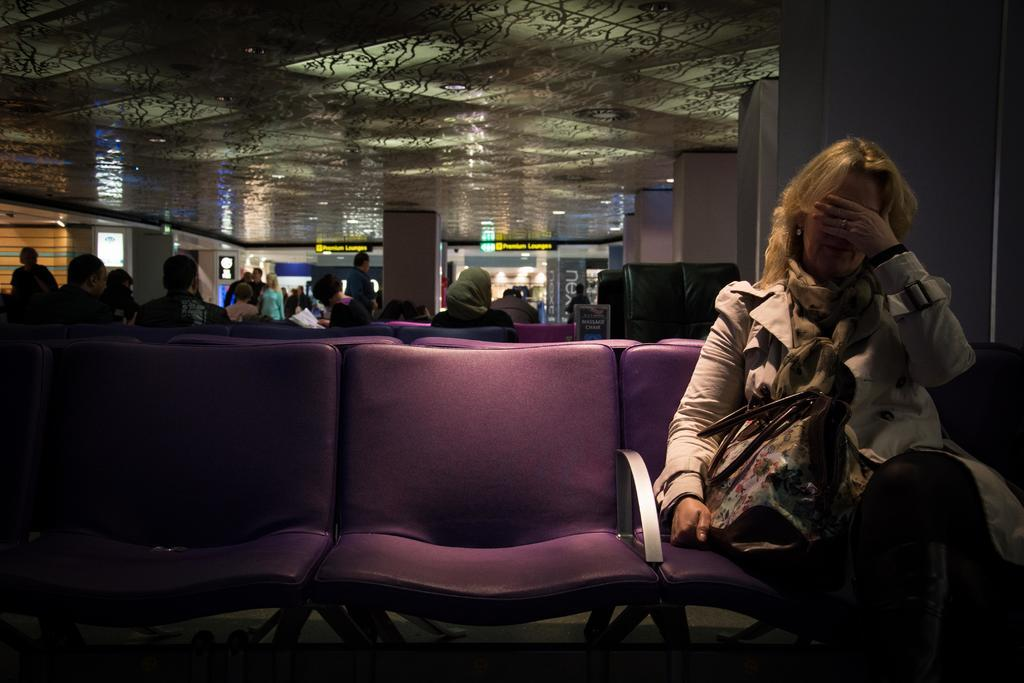Who is the main subject in the image? There is a woman in the image. What is the woman doing in the image? The woman is sitting on a chair with her eyes closed and her hand on her face. What is the woman holding in the image? The woman is holding a bag. Are there any other people visible in the image? Yes, there are other people behind the woman. What type of record can be seen playing on the ship in the image? There is no record or ship present in the image; it features a woman sitting on a chair with her eyes closed and her hand on her face. 